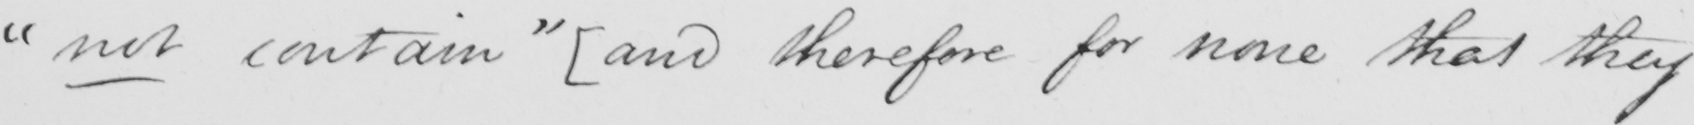What is written in this line of handwriting? " not contain "   [ and therefore for none that they 